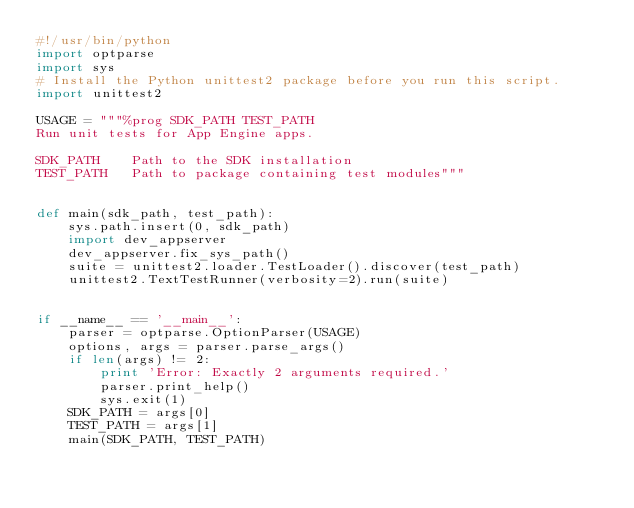Convert code to text. <code><loc_0><loc_0><loc_500><loc_500><_Python_>#!/usr/bin/python
import optparse
import sys
# Install the Python unittest2 package before you run this script.
import unittest2

USAGE = """%prog SDK_PATH TEST_PATH
Run unit tests for App Engine apps.

SDK_PATH    Path to the SDK installation
TEST_PATH   Path to package containing test modules"""


def main(sdk_path, test_path):
    sys.path.insert(0, sdk_path)
    import dev_appserver
    dev_appserver.fix_sys_path()
    suite = unittest2.loader.TestLoader().discover(test_path)
    unittest2.TextTestRunner(verbosity=2).run(suite)


if __name__ == '__main__':
    parser = optparse.OptionParser(USAGE)
    options, args = parser.parse_args()
    if len(args) != 2:
        print 'Error: Exactly 2 arguments required.'
        parser.print_help()
        sys.exit(1)
    SDK_PATH = args[0]
    TEST_PATH = args[1]
    main(SDK_PATH, TEST_PATH)</code> 